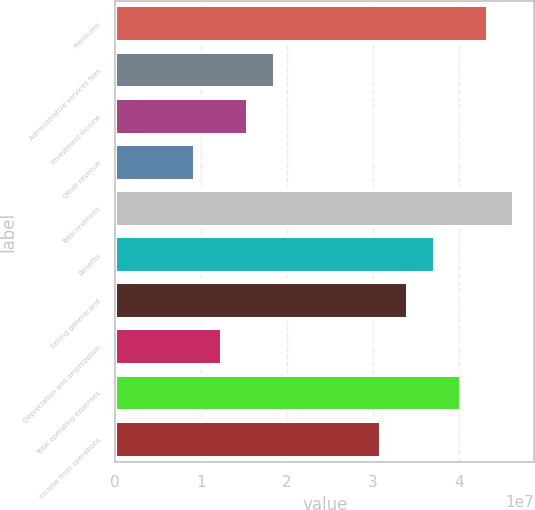<chart> <loc_0><loc_0><loc_500><loc_500><bar_chart><fcel>Premiums<fcel>Administrative services fees<fcel>Investment income<fcel>Other revenue<fcel>Total revenues<fcel>Benefits<fcel>Selling general and<fcel>Depreciation and amortization<fcel>Total operating expenses<fcel>Income from operations<nl><fcel>4.33446e+07<fcel>1.85763e+07<fcel>1.54802e+07<fcel>9.28813e+06<fcel>4.64406e+07<fcel>3.71525e+07<fcel>3.40565e+07<fcel>1.23842e+07<fcel>4.02485e+07<fcel>3.09604e+07<nl></chart> 